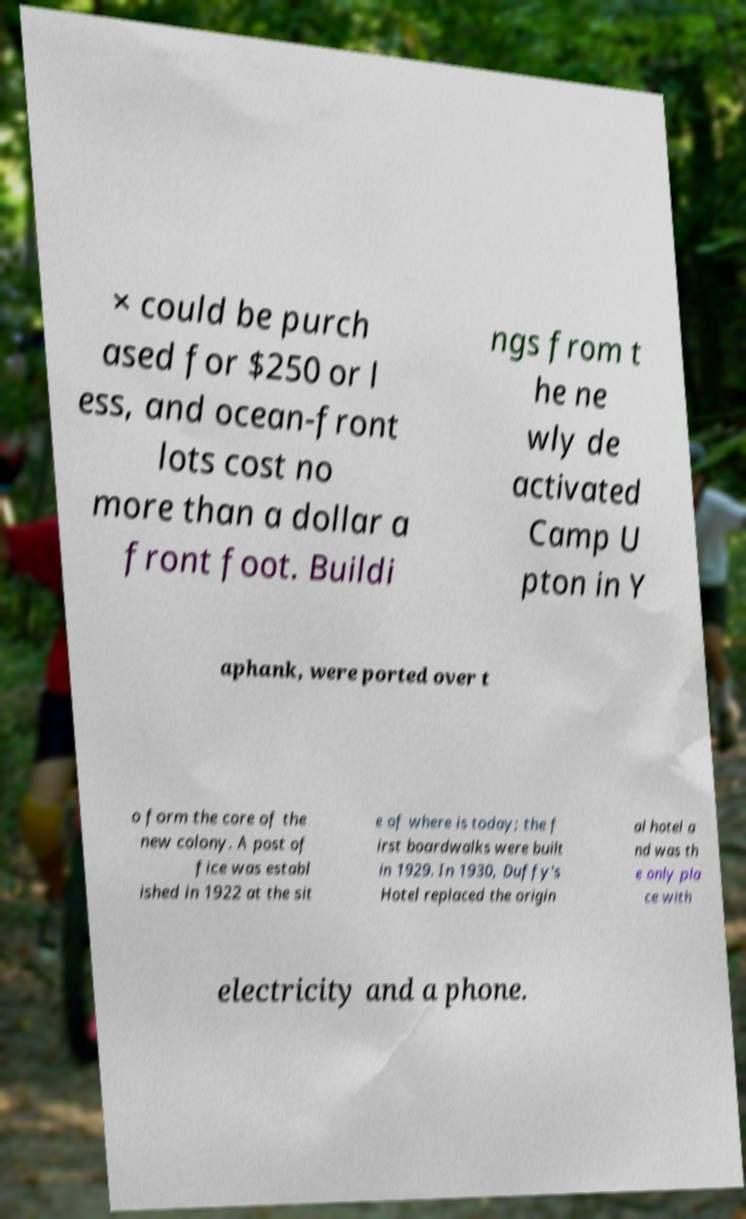What messages or text are displayed in this image? I need them in a readable, typed format. × could be purch ased for $250 or l ess, and ocean-front lots cost no more than a dollar a front foot. Buildi ngs from t he ne wly de activated Camp U pton in Y aphank, were ported over t o form the core of the new colony. A post of fice was establ ished in 1922 at the sit e of where is today; the f irst boardwalks were built in 1929. In 1930, Duffy's Hotel replaced the origin al hotel a nd was th e only pla ce with electricity and a phone. 